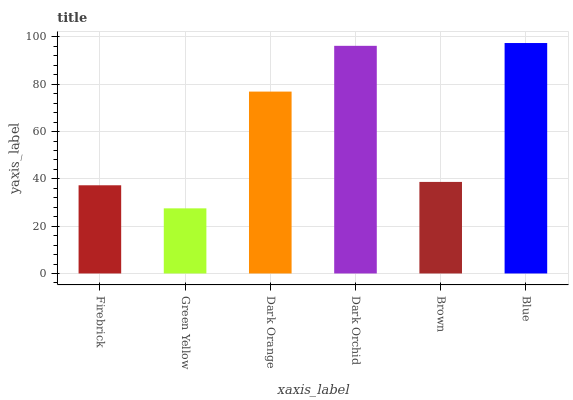Is Green Yellow the minimum?
Answer yes or no. Yes. Is Blue the maximum?
Answer yes or no. Yes. Is Dark Orange the minimum?
Answer yes or no. No. Is Dark Orange the maximum?
Answer yes or no. No. Is Dark Orange greater than Green Yellow?
Answer yes or no. Yes. Is Green Yellow less than Dark Orange?
Answer yes or no. Yes. Is Green Yellow greater than Dark Orange?
Answer yes or no. No. Is Dark Orange less than Green Yellow?
Answer yes or no. No. Is Dark Orange the high median?
Answer yes or no. Yes. Is Brown the low median?
Answer yes or no. Yes. Is Blue the high median?
Answer yes or no. No. Is Firebrick the low median?
Answer yes or no. No. 